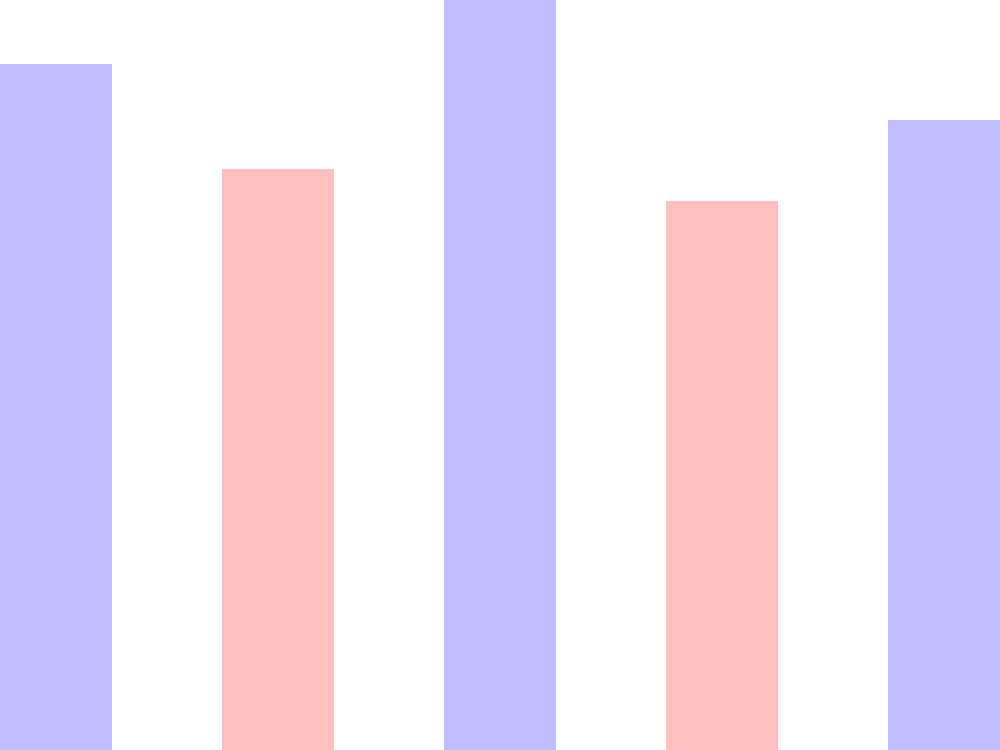A language learning company wants to assess the performance of various products in the market. The bar graph shows the user engagement scores for five popular language learning apps. Which two products have a combined user engagement score that is closest to 180? To solve this problem, we need to follow these steps:

1. Identify the user engagement scores for each product:
   - DuoLingo: 85
   - Babbel: 72
   - Rosetta Stone: 93
   - Busuu: 68
   - Memrise: 78

2. Calculate the combined scores for all possible pairs of products:
   - DuoLingo + Babbel = 85 + 72 = 157
   - DuoLingo + Rosetta Stone = 85 + 93 = 178
   - DuoLingo + Busuu = 85 + 68 = 153
   - DuoLingo + Memrise = 85 + 78 = 163
   - Babbel + Rosetta Stone = 72 + 93 = 165
   - Babbel + Busuu = 72 + 68 = 140
   - Babbel + Memrise = 72 + 78 = 150
   - Rosetta Stone + Busuu = 93 + 68 = 161
   - Rosetta Stone + Memrise = 93 + 78 = 171
   - Busuu + Memrise = 68 + 78 = 146

3. Find the pair with a combined score closest to 180:
   The pair with the closest combined score to 180 is DuoLingo and Rosetta Stone, with a total of 178.
Answer: DuoLingo and Rosetta Stone 